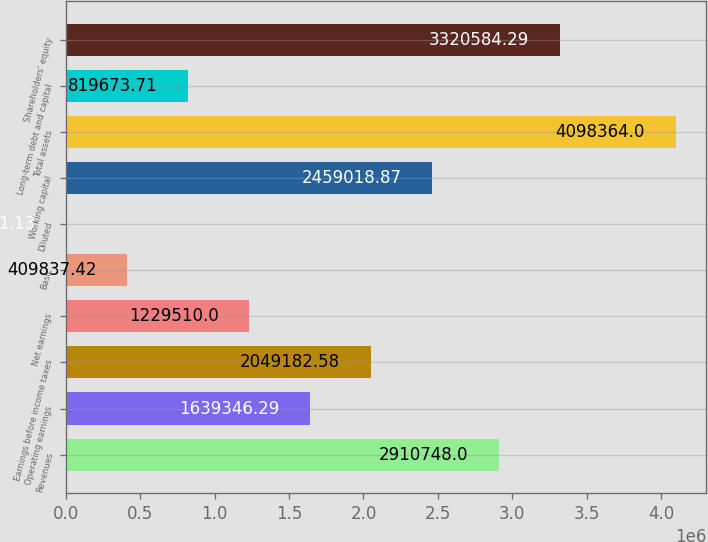<chart> <loc_0><loc_0><loc_500><loc_500><bar_chart><fcel>Revenues<fcel>Operating earnings<fcel>Earnings before income taxes<fcel>Net earnings<fcel>Basic<fcel>Diluted<fcel>Working capital<fcel>Total assets<fcel>Long-term debt and capital<fcel>Shareholders' equity<nl><fcel>2.91075e+06<fcel>1.63935e+06<fcel>2.04918e+06<fcel>1.22951e+06<fcel>409837<fcel>1.13<fcel>2.45902e+06<fcel>4.09836e+06<fcel>819674<fcel>3.32058e+06<nl></chart> 